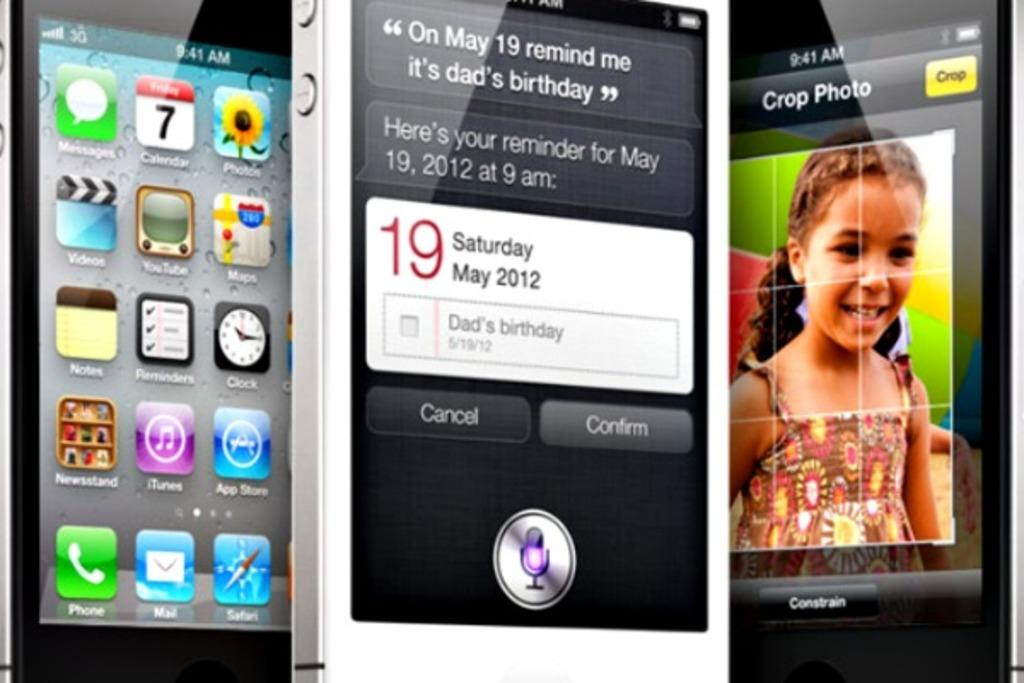Provide a one-sentence caption for the provided image. three phones in upright position , one in middle has a reminder for dads birthday on may 19. 